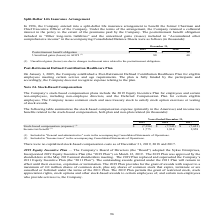According to Sykes Enterprises Incorporated's financial document, Where is stock-based compensation (expense) included? in "General and administrative" costs in the accompanying Consolidated Statements of Operations.. The document states: "(1) Included in "General and administrative" costs in the accompanying Consolidated Statements of Operations. (2) Included in "Income taxes" in the ac..." Also, Where is Income tax benefit included? in "Income taxes" in the accompanying Consolidated Statements of Operations.. The document states: "onsolidated Statements of Operations. (2) Included in "Income taxes" in the accompanying Consolidated Statements of Operations...." Also, In which years is income tax benefit calculated? The document contains multiple relevant values: 2019, 2018, 2017. From the document: "2019 2018 2017 2019 2018 2017 2019 2018 2017..." Additionally, In which year was the income tax benefit smallest? According to the financial document, 2019. The relevant text states: "2019 2018 2017..." Also, can you calculate: What was the change in income tax benefit in 2019 from 2018? Based on the calculation: 1,775-1,810, the result is -35 (in thousands). This is based on the information: "Income tax benefit (2) 1,775 1,810 2,858 Income tax benefit (2) 1,775 1,810 2,858..." The key data points involved are: 1,775, 1,810. Also, can you calculate: What was the percentage change in income tax benefit in 2019 from 2018? To answer this question, I need to perform calculations using the financial data. The calculation is: (1,775-1,810)/1,810, which equals -1.93 (percentage). This is based on the information: "Income tax benefit (2) 1,775 1,810 2,858 Income tax benefit (2) 1,775 1,810 2,858..." The key data points involved are: 1,775, 1,810. 